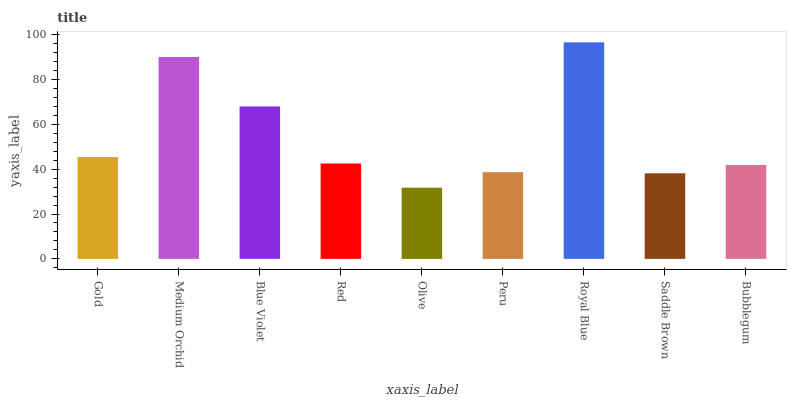Is Olive the minimum?
Answer yes or no. Yes. Is Royal Blue the maximum?
Answer yes or no. Yes. Is Medium Orchid the minimum?
Answer yes or no. No. Is Medium Orchid the maximum?
Answer yes or no. No. Is Medium Orchid greater than Gold?
Answer yes or no. Yes. Is Gold less than Medium Orchid?
Answer yes or no. Yes. Is Gold greater than Medium Orchid?
Answer yes or no. No. Is Medium Orchid less than Gold?
Answer yes or no. No. Is Red the high median?
Answer yes or no. Yes. Is Red the low median?
Answer yes or no. Yes. Is Bubblegum the high median?
Answer yes or no. No. Is Olive the low median?
Answer yes or no. No. 